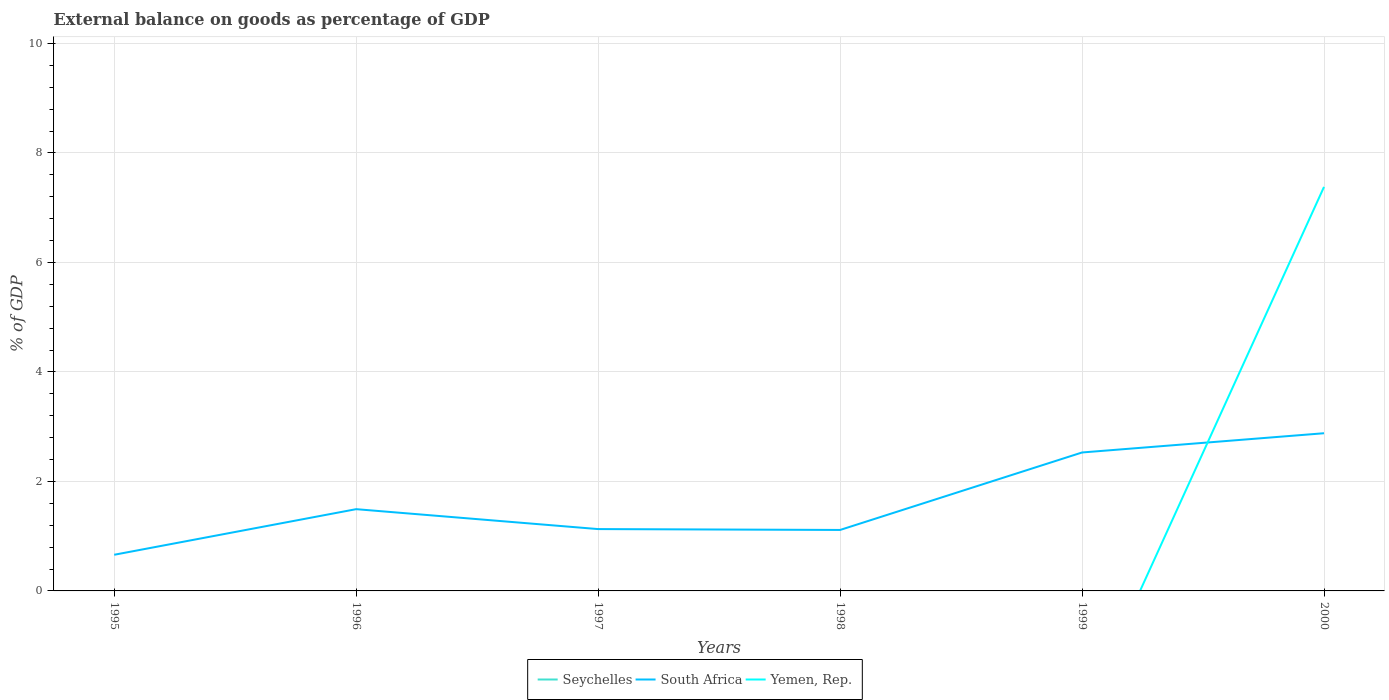How many different coloured lines are there?
Offer a very short reply. 2. Does the line corresponding to Yemen, Rep. intersect with the line corresponding to South Africa?
Offer a terse response. Yes. Is the number of lines equal to the number of legend labels?
Your response must be concise. No. What is the total external balance on goods as percentage of GDP in South Africa in the graph?
Your response must be concise. -0.35. What is the difference between the highest and the second highest external balance on goods as percentage of GDP in Yemen, Rep.?
Make the answer very short. 7.38. What is the difference between the highest and the lowest external balance on goods as percentage of GDP in Seychelles?
Offer a terse response. 0. How many years are there in the graph?
Make the answer very short. 6. What is the difference between two consecutive major ticks on the Y-axis?
Make the answer very short. 2. Are the values on the major ticks of Y-axis written in scientific E-notation?
Provide a succinct answer. No. Does the graph contain any zero values?
Provide a short and direct response. Yes. Does the graph contain grids?
Give a very brief answer. Yes. Where does the legend appear in the graph?
Keep it short and to the point. Bottom center. How many legend labels are there?
Provide a short and direct response. 3. What is the title of the graph?
Provide a short and direct response. External balance on goods as percentage of GDP. Does "Congo (Democratic)" appear as one of the legend labels in the graph?
Keep it short and to the point. No. What is the label or title of the X-axis?
Make the answer very short. Years. What is the label or title of the Y-axis?
Provide a short and direct response. % of GDP. What is the % of GDP of Seychelles in 1995?
Offer a terse response. 0. What is the % of GDP of South Africa in 1995?
Ensure brevity in your answer.  0.66. What is the % of GDP in Yemen, Rep. in 1995?
Offer a very short reply. 0. What is the % of GDP in South Africa in 1996?
Make the answer very short. 1.49. What is the % of GDP in Yemen, Rep. in 1996?
Your answer should be very brief. 0. What is the % of GDP in Seychelles in 1997?
Your response must be concise. 0. What is the % of GDP in South Africa in 1997?
Your answer should be compact. 1.13. What is the % of GDP in Yemen, Rep. in 1997?
Keep it short and to the point. 0. What is the % of GDP of South Africa in 1998?
Give a very brief answer. 1.11. What is the % of GDP in South Africa in 1999?
Provide a short and direct response. 2.53. What is the % of GDP in Seychelles in 2000?
Give a very brief answer. 0. What is the % of GDP of South Africa in 2000?
Provide a short and direct response. 2.88. What is the % of GDP in Yemen, Rep. in 2000?
Your answer should be very brief. 7.38. Across all years, what is the maximum % of GDP of South Africa?
Your answer should be very brief. 2.88. Across all years, what is the maximum % of GDP in Yemen, Rep.?
Provide a succinct answer. 7.38. Across all years, what is the minimum % of GDP of South Africa?
Keep it short and to the point. 0.66. Across all years, what is the minimum % of GDP in Yemen, Rep.?
Your response must be concise. 0. What is the total % of GDP in South Africa in the graph?
Provide a short and direct response. 9.8. What is the total % of GDP of Yemen, Rep. in the graph?
Offer a terse response. 7.38. What is the difference between the % of GDP in South Africa in 1995 and that in 1996?
Your answer should be compact. -0.83. What is the difference between the % of GDP in South Africa in 1995 and that in 1997?
Provide a short and direct response. -0.47. What is the difference between the % of GDP of South Africa in 1995 and that in 1998?
Your answer should be very brief. -0.45. What is the difference between the % of GDP of South Africa in 1995 and that in 1999?
Offer a very short reply. -1.87. What is the difference between the % of GDP of South Africa in 1995 and that in 2000?
Keep it short and to the point. -2.22. What is the difference between the % of GDP in South Africa in 1996 and that in 1997?
Make the answer very short. 0.36. What is the difference between the % of GDP of South Africa in 1996 and that in 1998?
Make the answer very short. 0.38. What is the difference between the % of GDP in South Africa in 1996 and that in 1999?
Offer a terse response. -1.04. What is the difference between the % of GDP of South Africa in 1996 and that in 2000?
Ensure brevity in your answer.  -1.39. What is the difference between the % of GDP of South Africa in 1997 and that in 1998?
Ensure brevity in your answer.  0.02. What is the difference between the % of GDP of South Africa in 1997 and that in 1999?
Your response must be concise. -1.4. What is the difference between the % of GDP in South Africa in 1997 and that in 2000?
Your answer should be compact. -1.75. What is the difference between the % of GDP in South Africa in 1998 and that in 1999?
Provide a short and direct response. -1.42. What is the difference between the % of GDP of South Africa in 1998 and that in 2000?
Keep it short and to the point. -1.77. What is the difference between the % of GDP of South Africa in 1999 and that in 2000?
Give a very brief answer. -0.35. What is the difference between the % of GDP of South Africa in 1995 and the % of GDP of Yemen, Rep. in 2000?
Your answer should be compact. -6.72. What is the difference between the % of GDP of South Africa in 1996 and the % of GDP of Yemen, Rep. in 2000?
Provide a short and direct response. -5.89. What is the difference between the % of GDP in South Africa in 1997 and the % of GDP in Yemen, Rep. in 2000?
Your answer should be compact. -6.25. What is the difference between the % of GDP in South Africa in 1998 and the % of GDP in Yemen, Rep. in 2000?
Provide a succinct answer. -6.27. What is the difference between the % of GDP of South Africa in 1999 and the % of GDP of Yemen, Rep. in 2000?
Give a very brief answer. -4.85. What is the average % of GDP of South Africa per year?
Your response must be concise. 1.63. What is the average % of GDP in Yemen, Rep. per year?
Offer a terse response. 1.23. In the year 2000, what is the difference between the % of GDP in South Africa and % of GDP in Yemen, Rep.?
Your answer should be very brief. -4.5. What is the ratio of the % of GDP in South Africa in 1995 to that in 1996?
Provide a short and direct response. 0.44. What is the ratio of the % of GDP in South Africa in 1995 to that in 1997?
Your response must be concise. 0.58. What is the ratio of the % of GDP in South Africa in 1995 to that in 1998?
Your answer should be very brief. 0.59. What is the ratio of the % of GDP of South Africa in 1995 to that in 1999?
Your answer should be very brief. 0.26. What is the ratio of the % of GDP in South Africa in 1995 to that in 2000?
Your response must be concise. 0.23. What is the ratio of the % of GDP of South Africa in 1996 to that in 1997?
Keep it short and to the point. 1.32. What is the ratio of the % of GDP of South Africa in 1996 to that in 1998?
Your response must be concise. 1.34. What is the ratio of the % of GDP in South Africa in 1996 to that in 1999?
Provide a short and direct response. 0.59. What is the ratio of the % of GDP of South Africa in 1996 to that in 2000?
Offer a very short reply. 0.52. What is the ratio of the % of GDP of South Africa in 1997 to that in 1998?
Ensure brevity in your answer.  1.01. What is the ratio of the % of GDP in South Africa in 1997 to that in 1999?
Offer a very short reply. 0.45. What is the ratio of the % of GDP of South Africa in 1997 to that in 2000?
Ensure brevity in your answer.  0.39. What is the ratio of the % of GDP of South Africa in 1998 to that in 1999?
Offer a terse response. 0.44. What is the ratio of the % of GDP in South Africa in 1998 to that in 2000?
Offer a very short reply. 0.39. What is the ratio of the % of GDP in South Africa in 1999 to that in 2000?
Your answer should be very brief. 0.88. What is the difference between the highest and the second highest % of GDP in South Africa?
Keep it short and to the point. 0.35. What is the difference between the highest and the lowest % of GDP in South Africa?
Provide a short and direct response. 2.22. What is the difference between the highest and the lowest % of GDP in Yemen, Rep.?
Your response must be concise. 7.38. 